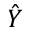Convert formula to latex. <formula><loc_0><loc_0><loc_500><loc_500>\hat { Y }</formula> 